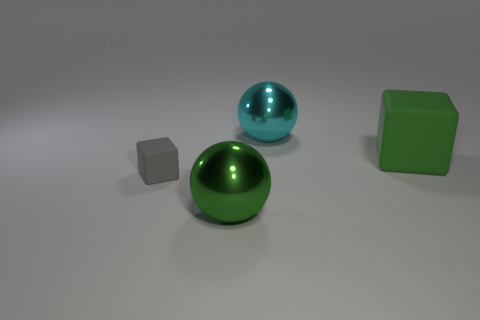Are there any large green balls in front of the cyan thing?
Keep it short and to the point. Yes. There is a metal object that is in front of the cube left of the green thing that is in front of the small gray block; what size is it?
Your response must be concise. Large. Is the shape of the large green object that is to the right of the big cyan metal sphere the same as the big green thing in front of the tiny object?
Your answer should be very brief. No. There is a green matte object that is the same shape as the gray thing; what is its size?
Offer a very short reply. Large. What number of other large green cubes have the same material as the large green cube?
Give a very brief answer. 0. What is the material of the green sphere?
Provide a succinct answer. Metal. What shape is the thing that is in front of the rubber block in front of the big cube?
Offer a very short reply. Sphere. There is a green object that is to the left of the big cyan thing; what shape is it?
Keep it short and to the point. Sphere. What number of big shiny objects have the same color as the large rubber cube?
Give a very brief answer. 1. What is the color of the small cube?
Ensure brevity in your answer.  Gray. 